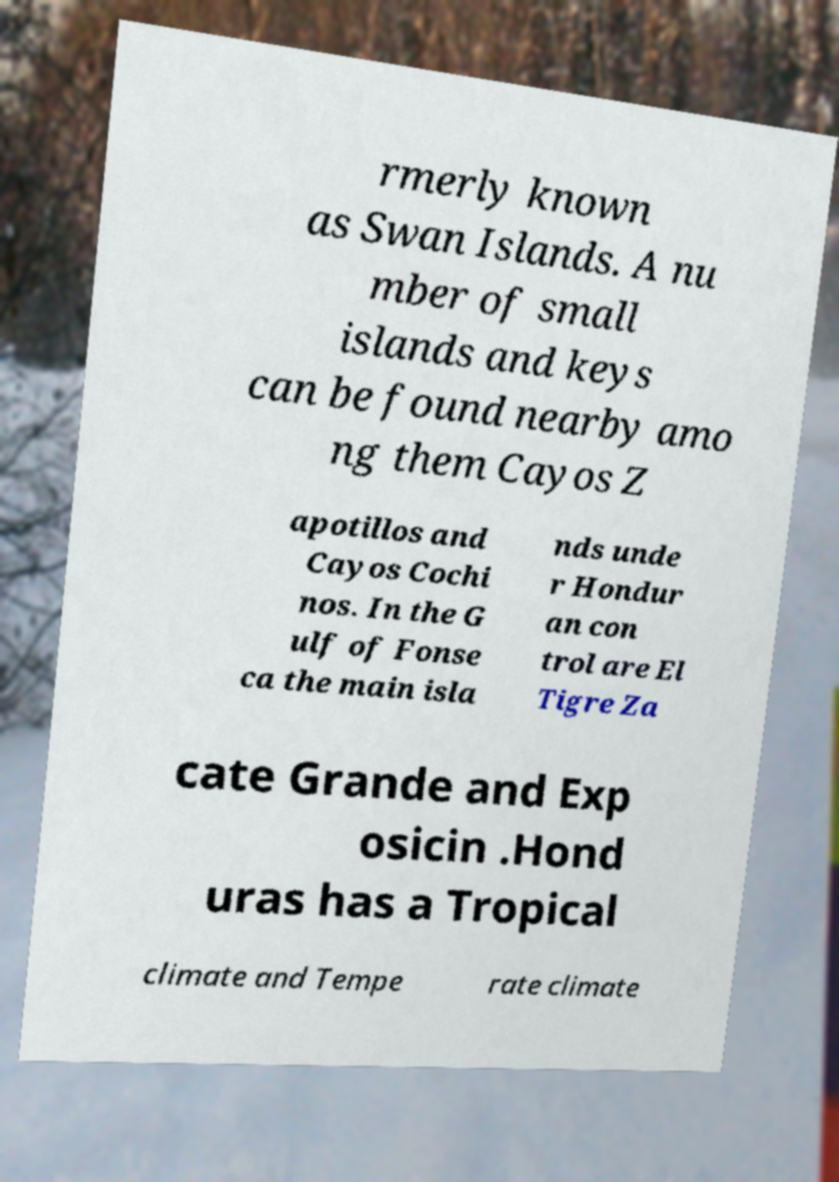Can you accurately transcribe the text from the provided image for me? rmerly known as Swan Islands. A nu mber of small islands and keys can be found nearby amo ng them Cayos Z apotillos and Cayos Cochi nos. In the G ulf of Fonse ca the main isla nds unde r Hondur an con trol are El Tigre Za cate Grande and Exp osicin .Hond uras has a Tropical climate and Tempe rate climate 